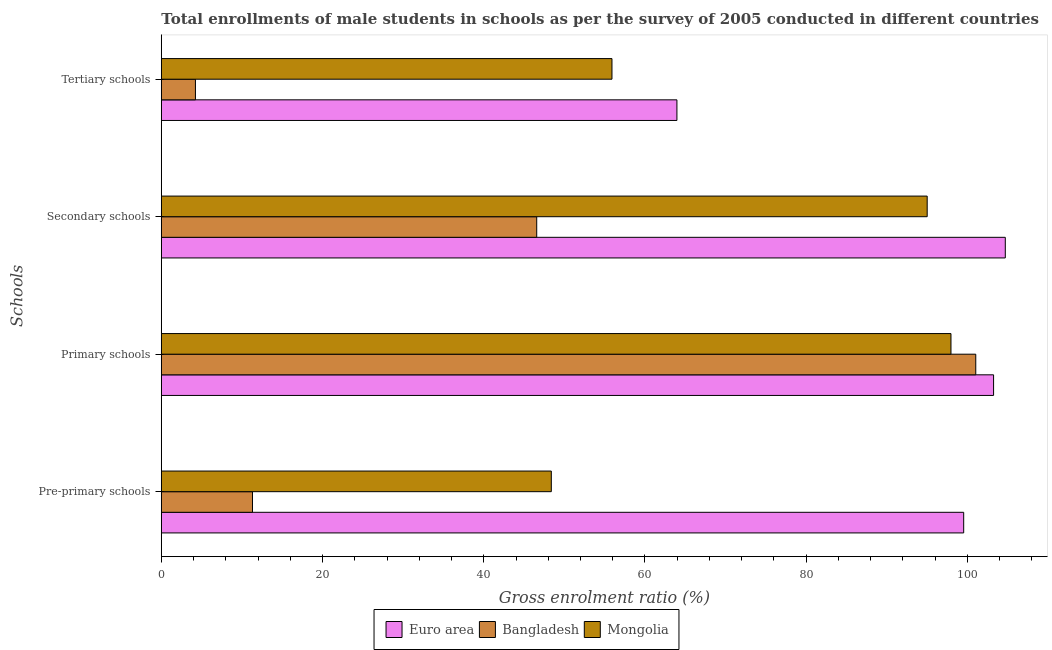How many groups of bars are there?
Ensure brevity in your answer.  4. Are the number of bars on each tick of the Y-axis equal?
Your response must be concise. Yes. How many bars are there on the 2nd tick from the top?
Offer a terse response. 3. How many bars are there on the 1st tick from the bottom?
Provide a succinct answer. 3. What is the label of the 3rd group of bars from the top?
Your response must be concise. Primary schools. What is the gross enrolment ratio(male) in tertiary schools in Euro area?
Your answer should be very brief. 63.96. Across all countries, what is the maximum gross enrolment ratio(male) in tertiary schools?
Keep it short and to the point. 63.96. Across all countries, what is the minimum gross enrolment ratio(male) in pre-primary schools?
Offer a terse response. 11.31. In which country was the gross enrolment ratio(male) in primary schools minimum?
Offer a terse response. Mongolia. What is the total gross enrolment ratio(male) in pre-primary schools in the graph?
Offer a terse response. 159.23. What is the difference between the gross enrolment ratio(male) in secondary schools in Bangladesh and that in Euro area?
Offer a very short reply. -58.13. What is the difference between the gross enrolment ratio(male) in pre-primary schools in Euro area and the gross enrolment ratio(male) in primary schools in Mongolia?
Offer a terse response. 1.58. What is the average gross enrolment ratio(male) in secondary schools per country?
Your answer should be very brief. 82.09. What is the difference between the gross enrolment ratio(male) in secondary schools and gross enrolment ratio(male) in pre-primary schools in Bangladesh?
Keep it short and to the point. 35.26. In how many countries, is the gross enrolment ratio(male) in secondary schools greater than 48 %?
Give a very brief answer. 2. What is the ratio of the gross enrolment ratio(male) in pre-primary schools in Mongolia to that in Bangladesh?
Make the answer very short. 4.28. What is the difference between the highest and the second highest gross enrolment ratio(male) in secondary schools?
Your answer should be compact. 9.69. What is the difference between the highest and the lowest gross enrolment ratio(male) in primary schools?
Offer a terse response. 5.29. What does the 3rd bar from the top in Primary schools represents?
Give a very brief answer. Euro area. How many bars are there?
Your answer should be compact. 12. Are all the bars in the graph horizontal?
Offer a terse response. Yes. Are the values on the major ticks of X-axis written in scientific E-notation?
Keep it short and to the point. No. Does the graph contain any zero values?
Your response must be concise. No. Where does the legend appear in the graph?
Your answer should be compact. Bottom center. How many legend labels are there?
Make the answer very short. 3. What is the title of the graph?
Ensure brevity in your answer.  Total enrollments of male students in schools as per the survey of 2005 conducted in different countries. Does "Pakistan" appear as one of the legend labels in the graph?
Make the answer very short. No. What is the label or title of the X-axis?
Ensure brevity in your answer.  Gross enrolment ratio (%). What is the label or title of the Y-axis?
Provide a short and direct response. Schools. What is the Gross enrolment ratio (%) of Euro area in Pre-primary schools?
Your response must be concise. 99.54. What is the Gross enrolment ratio (%) in Bangladesh in Pre-primary schools?
Provide a succinct answer. 11.31. What is the Gross enrolment ratio (%) of Mongolia in Pre-primary schools?
Provide a succinct answer. 48.38. What is the Gross enrolment ratio (%) of Euro area in Primary schools?
Offer a very short reply. 103.25. What is the Gross enrolment ratio (%) in Bangladesh in Primary schools?
Keep it short and to the point. 101.04. What is the Gross enrolment ratio (%) in Mongolia in Primary schools?
Keep it short and to the point. 97.96. What is the Gross enrolment ratio (%) in Euro area in Secondary schools?
Keep it short and to the point. 104.7. What is the Gross enrolment ratio (%) in Bangladesh in Secondary schools?
Your answer should be very brief. 46.57. What is the Gross enrolment ratio (%) of Mongolia in Secondary schools?
Your response must be concise. 95.01. What is the Gross enrolment ratio (%) in Euro area in Tertiary schools?
Your answer should be compact. 63.96. What is the Gross enrolment ratio (%) in Bangladesh in Tertiary schools?
Offer a terse response. 4.23. What is the Gross enrolment ratio (%) of Mongolia in Tertiary schools?
Offer a terse response. 55.91. Across all Schools, what is the maximum Gross enrolment ratio (%) in Euro area?
Give a very brief answer. 104.7. Across all Schools, what is the maximum Gross enrolment ratio (%) of Bangladesh?
Your answer should be very brief. 101.04. Across all Schools, what is the maximum Gross enrolment ratio (%) in Mongolia?
Your answer should be very brief. 97.96. Across all Schools, what is the minimum Gross enrolment ratio (%) of Euro area?
Your answer should be compact. 63.96. Across all Schools, what is the minimum Gross enrolment ratio (%) of Bangladesh?
Give a very brief answer. 4.23. Across all Schools, what is the minimum Gross enrolment ratio (%) of Mongolia?
Provide a succinct answer. 48.38. What is the total Gross enrolment ratio (%) of Euro area in the graph?
Make the answer very short. 371.45. What is the total Gross enrolment ratio (%) in Bangladesh in the graph?
Make the answer very short. 163.15. What is the total Gross enrolment ratio (%) of Mongolia in the graph?
Offer a terse response. 297.26. What is the difference between the Gross enrolment ratio (%) of Euro area in Pre-primary schools and that in Primary schools?
Keep it short and to the point. -3.71. What is the difference between the Gross enrolment ratio (%) in Bangladesh in Pre-primary schools and that in Primary schools?
Offer a terse response. -89.73. What is the difference between the Gross enrolment ratio (%) in Mongolia in Pre-primary schools and that in Primary schools?
Your answer should be compact. -49.58. What is the difference between the Gross enrolment ratio (%) of Euro area in Pre-primary schools and that in Secondary schools?
Your response must be concise. -5.16. What is the difference between the Gross enrolment ratio (%) of Bangladesh in Pre-primary schools and that in Secondary schools?
Your answer should be compact. -35.26. What is the difference between the Gross enrolment ratio (%) in Mongolia in Pre-primary schools and that in Secondary schools?
Keep it short and to the point. -46.63. What is the difference between the Gross enrolment ratio (%) of Euro area in Pre-primary schools and that in Tertiary schools?
Your answer should be very brief. 35.58. What is the difference between the Gross enrolment ratio (%) in Bangladesh in Pre-primary schools and that in Tertiary schools?
Provide a succinct answer. 7.08. What is the difference between the Gross enrolment ratio (%) of Mongolia in Pre-primary schools and that in Tertiary schools?
Your answer should be compact. -7.53. What is the difference between the Gross enrolment ratio (%) in Euro area in Primary schools and that in Secondary schools?
Provide a short and direct response. -1.45. What is the difference between the Gross enrolment ratio (%) of Bangladesh in Primary schools and that in Secondary schools?
Your response must be concise. 54.47. What is the difference between the Gross enrolment ratio (%) of Mongolia in Primary schools and that in Secondary schools?
Keep it short and to the point. 2.95. What is the difference between the Gross enrolment ratio (%) of Euro area in Primary schools and that in Tertiary schools?
Keep it short and to the point. 39.28. What is the difference between the Gross enrolment ratio (%) of Bangladesh in Primary schools and that in Tertiary schools?
Your answer should be very brief. 96.81. What is the difference between the Gross enrolment ratio (%) in Mongolia in Primary schools and that in Tertiary schools?
Offer a terse response. 42.05. What is the difference between the Gross enrolment ratio (%) of Euro area in Secondary schools and that in Tertiary schools?
Offer a very short reply. 40.74. What is the difference between the Gross enrolment ratio (%) in Bangladesh in Secondary schools and that in Tertiary schools?
Provide a short and direct response. 42.34. What is the difference between the Gross enrolment ratio (%) of Mongolia in Secondary schools and that in Tertiary schools?
Give a very brief answer. 39.1. What is the difference between the Gross enrolment ratio (%) of Euro area in Pre-primary schools and the Gross enrolment ratio (%) of Bangladesh in Primary schools?
Provide a succinct answer. -1.5. What is the difference between the Gross enrolment ratio (%) in Euro area in Pre-primary schools and the Gross enrolment ratio (%) in Mongolia in Primary schools?
Your response must be concise. 1.58. What is the difference between the Gross enrolment ratio (%) in Bangladesh in Pre-primary schools and the Gross enrolment ratio (%) in Mongolia in Primary schools?
Your response must be concise. -86.65. What is the difference between the Gross enrolment ratio (%) in Euro area in Pre-primary schools and the Gross enrolment ratio (%) in Bangladesh in Secondary schools?
Make the answer very short. 52.97. What is the difference between the Gross enrolment ratio (%) of Euro area in Pre-primary schools and the Gross enrolment ratio (%) of Mongolia in Secondary schools?
Ensure brevity in your answer.  4.53. What is the difference between the Gross enrolment ratio (%) in Bangladesh in Pre-primary schools and the Gross enrolment ratio (%) in Mongolia in Secondary schools?
Provide a short and direct response. -83.7. What is the difference between the Gross enrolment ratio (%) of Euro area in Pre-primary schools and the Gross enrolment ratio (%) of Bangladesh in Tertiary schools?
Ensure brevity in your answer.  95.31. What is the difference between the Gross enrolment ratio (%) of Euro area in Pre-primary schools and the Gross enrolment ratio (%) of Mongolia in Tertiary schools?
Make the answer very short. 43.63. What is the difference between the Gross enrolment ratio (%) of Bangladesh in Pre-primary schools and the Gross enrolment ratio (%) of Mongolia in Tertiary schools?
Your answer should be very brief. -44.6. What is the difference between the Gross enrolment ratio (%) in Euro area in Primary schools and the Gross enrolment ratio (%) in Bangladesh in Secondary schools?
Keep it short and to the point. 56.68. What is the difference between the Gross enrolment ratio (%) of Euro area in Primary schools and the Gross enrolment ratio (%) of Mongolia in Secondary schools?
Your answer should be very brief. 8.24. What is the difference between the Gross enrolment ratio (%) of Bangladesh in Primary schools and the Gross enrolment ratio (%) of Mongolia in Secondary schools?
Make the answer very short. 6.03. What is the difference between the Gross enrolment ratio (%) in Euro area in Primary schools and the Gross enrolment ratio (%) in Bangladesh in Tertiary schools?
Your answer should be very brief. 99.02. What is the difference between the Gross enrolment ratio (%) of Euro area in Primary schools and the Gross enrolment ratio (%) of Mongolia in Tertiary schools?
Give a very brief answer. 47.34. What is the difference between the Gross enrolment ratio (%) in Bangladesh in Primary schools and the Gross enrolment ratio (%) in Mongolia in Tertiary schools?
Ensure brevity in your answer.  45.13. What is the difference between the Gross enrolment ratio (%) of Euro area in Secondary schools and the Gross enrolment ratio (%) of Bangladesh in Tertiary schools?
Provide a short and direct response. 100.47. What is the difference between the Gross enrolment ratio (%) of Euro area in Secondary schools and the Gross enrolment ratio (%) of Mongolia in Tertiary schools?
Make the answer very short. 48.79. What is the difference between the Gross enrolment ratio (%) in Bangladesh in Secondary schools and the Gross enrolment ratio (%) in Mongolia in Tertiary schools?
Ensure brevity in your answer.  -9.34. What is the average Gross enrolment ratio (%) of Euro area per Schools?
Your answer should be very brief. 92.86. What is the average Gross enrolment ratio (%) of Bangladesh per Schools?
Keep it short and to the point. 40.79. What is the average Gross enrolment ratio (%) of Mongolia per Schools?
Offer a terse response. 74.32. What is the difference between the Gross enrolment ratio (%) of Euro area and Gross enrolment ratio (%) of Bangladesh in Pre-primary schools?
Provide a short and direct response. 88.23. What is the difference between the Gross enrolment ratio (%) of Euro area and Gross enrolment ratio (%) of Mongolia in Pre-primary schools?
Provide a succinct answer. 51.16. What is the difference between the Gross enrolment ratio (%) of Bangladesh and Gross enrolment ratio (%) of Mongolia in Pre-primary schools?
Keep it short and to the point. -37.07. What is the difference between the Gross enrolment ratio (%) of Euro area and Gross enrolment ratio (%) of Bangladesh in Primary schools?
Your answer should be compact. 2.21. What is the difference between the Gross enrolment ratio (%) in Euro area and Gross enrolment ratio (%) in Mongolia in Primary schools?
Provide a short and direct response. 5.29. What is the difference between the Gross enrolment ratio (%) in Bangladesh and Gross enrolment ratio (%) in Mongolia in Primary schools?
Your answer should be very brief. 3.08. What is the difference between the Gross enrolment ratio (%) of Euro area and Gross enrolment ratio (%) of Bangladesh in Secondary schools?
Provide a short and direct response. 58.13. What is the difference between the Gross enrolment ratio (%) in Euro area and Gross enrolment ratio (%) in Mongolia in Secondary schools?
Your answer should be very brief. 9.69. What is the difference between the Gross enrolment ratio (%) in Bangladesh and Gross enrolment ratio (%) in Mongolia in Secondary schools?
Your answer should be very brief. -48.44. What is the difference between the Gross enrolment ratio (%) in Euro area and Gross enrolment ratio (%) in Bangladesh in Tertiary schools?
Offer a terse response. 59.73. What is the difference between the Gross enrolment ratio (%) in Euro area and Gross enrolment ratio (%) in Mongolia in Tertiary schools?
Make the answer very short. 8.06. What is the difference between the Gross enrolment ratio (%) in Bangladesh and Gross enrolment ratio (%) in Mongolia in Tertiary schools?
Provide a short and direct response. -51.67. What is the ratio of the Gross enrolment ratio (%) of Euro area in Pre-primary schools to that in Primary schools?
Provide a short and direct response. 0.96. What is the ratio of the Gross enrolment ratio (%) of Bangladesh in Pre-primary schools to that in Primary schools?
Keep it short and to the point. 0.11. What is the ratio of the Gross enrolment ratio (%) in Mongolia in Pre-primary schools to that in Primary schools?
Your response must be concise. 0.49. What is the ratio of the Gross enrolment ratio (%) in Euro area in Pre-primary schools to that in Secondary schools?
Your response must be concise. 0.95. What is the ratio of the Gross enrolment ratio (%) of Bangladesh in Pre-primary schools to that in Secondary schools?
Your response must be concise. 0.24. What is the ratio of the Gross enrolment ratio (%) of Mongolia in Pre-primary schools to that in Secondary schools?
Your answer should be very brief. 0.51. What is the ratio of the Gross enrolment ratio (%) of Euro area in Pre-primary schools to that in Tertiary schools?
Provide a succinct answer. 1.56. What is the ratio of the Gross enrolment ratio (%) of Bangladesh in Pre-primary schools to that in Tertiary schools?
Your answer should be compact. 2.67. What is the ratio of the Gross enrolment ratio (%) in Mongolia in Pre-primary schools to that in Tertiary schools?
Provide a succinct answer. 0.87. What is the ratio of the Gross enrolment ratio (%) of Euro area in Primary schools to that in Secondary schools?
Your answer should be compact. 0.99. What is the ratio of the Gross enrolment ratio (%) of Bangladesh in Primary schools to that in Secondary schools?
Provide a short and direct response. 2.17. What is the ratio of the Gross enrolment ratio (%) in Mongolia in Primary schools to that in Secondary schools?
Your answer should be very brief. 1.03. What is the ratio of the Gross enrolment ratio (%) of Euro area in Primary schools to that in Tertiary schools?
Your answer should be compact. 1.61. What is the ratio of the Gross enrolment ratio (%) in Bangladesh in Primary schools to that in Tertiary schools?
Provide a short and direct response. 23.87. What is the ratio of the Gross enrolment ratio (%) in Mongolia in Primary schools to that in Tertiary schools?
Keep it short and to the point. 1.75. What is the ratio of the Gross enrolment ratio (%) in Euro area in Secondary schools to that in Tertiary schools?
Your answer should be very brief. 1.64. What is the ratio of the Gross enrolment ratio (%) in Bangladesh in Secondary schools to that in Tertiary schools?
Your answer should be compact. 11. What is the ratio of the Gross enrolment ratio (%) of Mongolia in Secondary schools to that in Tertiary schools?
Give a very brief answer. 1.7. What is the difference between the highest and the second highest Gross enrolment ratio (%) of Euro area?
Your answer should be compact. 1.45. What is the difference between the highest and the second highest Gross enrolment ratio (%) of Bangladesh?
Make the answer very short. 54.47. What is the difference between the highest and the second highest Gross enrolment ratio (%) of Mongolia?
Provide a succinct answer. 2.95. What is the difference between the highest and the lowest Gross enrolment ratio (%) in Euro area?
Give a very brief answer. 40.74. What is the difference between the highest and the lowest Gross enrolment ratio (%) of Bangladesh?
Keep it short and to the point. 96.81. What is the difference between the highest and the lowest Gross enrolment ratio (%) in Mongolia?
Offer a terse response. 49.58. 